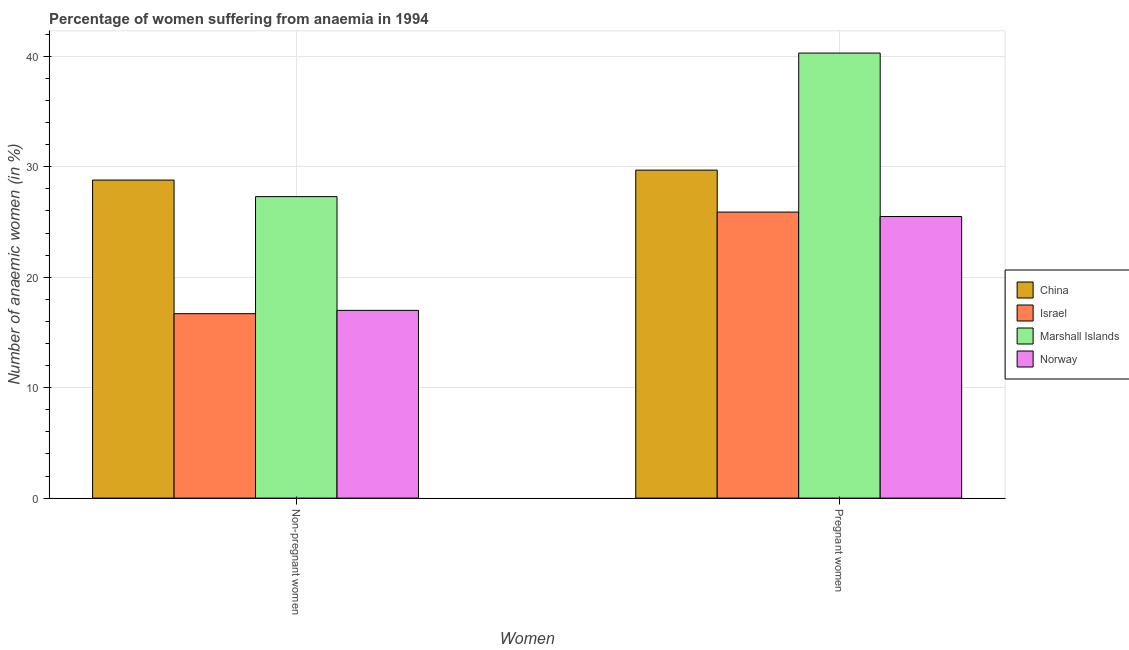How many different coloured bars are there?
Make the answer very short. 4. Are the number of bars per tick equal to the number of legend labels?
Give a very brief answer. Yes. Are the number of bars on each tick of the X-axis equal?
Make the answer very short. Yes. How many bars are there on the 1st tick from the left?
Your response must be concise. 4. What is the label of the 2nd group of bars from the left?
Provide a short and direct response. Pregnant women. What is the percentage of non-pregnant anaemic women in China?
Provide a succinct answer. 28.8. Across all countries, what is the maximum percentage of non-pregnant anaemic women?
Give a very brief answer. 28.8. Across all countries, what is the minimum percentage of pregnant anaemic women?
Make the answer very short. 25.5. What is the total percentage of non-pregnant anaemic women in the graph?
Offer a very short reply. 89.8. What is the difference between the percentage of non-pregnant anaemic women in China and that in Israel?
Offer a very short reply. 12.1. What is the difference between the percentage of pregnant anaemic women in Israel and the percentage of non-pregnant anaemic women in Marshall Islands?
Give a very brief answer. -1.4. What is the average percentage of pregnant anaemic women per country?
Your response must be concise. 30.35. What is the difference between the percentage of pregnant anaemic women and percentage of non-pregnant anaemic women in Marshall Islands?
Make the answer very short. 13. In how many countries, is the percentage of pregnant anaemic women greater than 12 %?
Your answer should be compact. 4. What is the ratio of the percentage of non-pregnant anaemic women in China to that in Norway?
Provide a short and direct response. 1.69. Is the percentage of non-pregnant anaemic women in Norway less than that in Israel?
Provide a succinct answer. No. In how many countries, is the percentage of pregnant anaemic women greater than the average percentage of pregnant anaemic women taken over all countries?
Make the answer very short. 1. What does the 3rd bar from the left in Non-pregnant women represents?
Offer a terse response. Marshall Islands. What does the 1st bar from the right in Non-pregnant women represents?
Make the answer very short. Norway. How many bars are there?
Provide a short and direct response. 8. Are all the bars in the graph horizontal?
Your response must be concise. No. How many countries are there in the graph?
Your answer should be compact. 4. Does the graph contain any zero values?
Offer a very short reply. No. Does the graph contain grids?
Ensure brevity in your answer.  Yes. Where does the legend appear in the graph?
Your answer should be very brief. Center right. How many legend labels are there?
Your answer should be compact. 4. What is the title of the graph?
Offer a very short reply. Percentage of women suffering from anaemia in 1994. What is the label or title of the X-axis?
Offer a very short reply. Women. What is the label or title of the Y-axis?
Your answer should be very brief. Number of anaemic women (in %). What is the Number of anaemic women (in %) of China in Non-pregnant women?
Provide a succinct answer. 28.8. What is the Number of anaemic women (in %) of Israel in Non-pregnant women?
Keep it short and to the point. 16.7. What is the Number of anaemic women (in %) in Marshall Islands in Non-pregnant women?
Ensure brevity in your answer.  27.3. What is the Number of anaemic women (in %) of China in Pregnant women?
Offer a terse response. 29.7. What is the Number of anaemic women (in %) of Israel in Pregnant women?
Your answer should be compact. 25.9. What is the Number of anaemic women (in %) of Marshall Islands in Pregnant women?
Make the answer very short. 40.3. What is the Number of anaemic women (in %) in Norway in Pregnant women?
Offer a terse response. 25.5. Across all Women, what is the maximum Number of anaemic women (in %) of China?
Provide a short and direct response. 29.7. Across all Women, what is the maximum Number of anaemic women (in %) of Israel?
Provide a short and direct response. 25.9. Across all Women, what is the maximum Number of anaemic women (in %) of Marshall Islands?
Your response must be concise. 40.3. Across all Women, what is the minimum Number of anaemic women (in %) in China?
Keep it short and to the point. 28.8. Across all Women, what is the minimum Number of anaemic women (in %) in Marshall Islands?
Ensure brevity in your answer.  27.3. Across all Women, what is the minimum Number of anaemic women (in %) of Norway?
Ensure brevity in your answer.  17. What is the total Number of anaemic women (in %) of China in the graph?
Provide a short and direct response. 58.5. What is the total Number of anaemic women (in %) in Israel in the graph?
Give a very brief answer. 42.6. What is the total Number of anaemic women (in %) of Marshall Islands in the graph?
Ensure brevity in your answer.  67.6. What is the total Number of anaemic women (in %) in Norway in the graph?
Your response must be concise. 42.5. What is the difference between the Number of anaemic women (in %) in Marshall Islands in Non-pregnant women and that in Pregnant women?
Your answer should be compact. -13. What is the difference between the Number of anaemic women (in %) of Norway in Non-pregnant women and that in Pregnant women?
Give a very brief answer. -8.5. What is the difference between the Number of anaemic women (in %) in China in Non-pregnant women and the Number of anaemic women (in %) in Norway in Pregnant women?
Give a very brief answer. 3.3. What is the difference between the Number of anaemic women (in %) in Israel in Non-pregnant women and the Number of anaemic women (in %) in Marshall Islands in Pregnant women?
Ensure brevity in your answer.  -23.6. What is the difference between the Number of anaemic women (in %) of Israel in Non-pregnant women and the Number of anaemic women (in %) of Norway in Pregnant women?
Provide a succinct answer. -8.8. What is the average Number of anaemic women (in %) in China per Women?
Your answer should be very brief. 29.25. What is the average Number of anaemic women (in %) of Israel per Women?
Provide a short and direct response. 21.3. What is the average Number of anaemic women (in %) of Marshall Islands per Women?
Give a very brief answer. 33.8. What is the average Number of anaemic women (in %) of Norway per Women?
Provide a succinct answer. 21.25. What is the difference between the Number of anaemic women (in %) of China and Number of anaemic women (in %) of Israel in Non-pregnant women?
Keep it short and to the point. 12.1. What is the difference between the Number of anaemic women (in %) of China and Number of anaemic women (in %) of Marshall Islands in Non-pregnant women?
Your response must be concise. 1.5. What is the difference between the Number of anaemic women (in %) of China and Number of anaemic women (in %) of Israel in Pregnant women?
Keep it short and to the point. 3.8. What is the difference between the Number of anaemic women (in %) of China and Number of anaemic women (in %) of Marshall Islands in Pregnant women?
Offer a terse response. -10.6. What is the difference between the Number of anaemic women (in %) of China and Number of anaemic women (in %) of Norway in Pregnant women?
Provide a short and direct response. 4.2. What is the difference between the Number of anaemic women (in %) of Israel and Number of anaemic women (in %) of Marshall Islands in Pregnant women?
Give a very brief answer. -14.4. What is the difference between the Number of anaemic women (in %) of Israel and Number of anaemic women (in %) of Norway in Pregnant women?
Provide a succinct answer. 0.4. What is the ratio of the Number of anaemic women (in %) of China in Non-pregnant women to that in Pregnant women?
Offer a terse response. 0.97. What is the ratio of the Number of anaemic women (in %) in Israel in Non-pregnant women to that in Pregnant women?
Offer a very short reply. 0.64. What is the ratio of the Number of anaemic women (in %) of Marshall Islands in Non-pregnant women to that in Pregnant women?
Your answer should be compact. 0.68. What is the difference between the highest and the second highest Number of anaemic women (in %) of Marshall Islands?
Provide a short and direct response. 13. What is the difference between the highest and the lowest Number of anaemic women (in %) of China?
Make the answer very short. 0.9. What is the difference between the highest and the lowest Number of anaemic women (in %) in Norway?
Give a very brief answer. 8.5. 